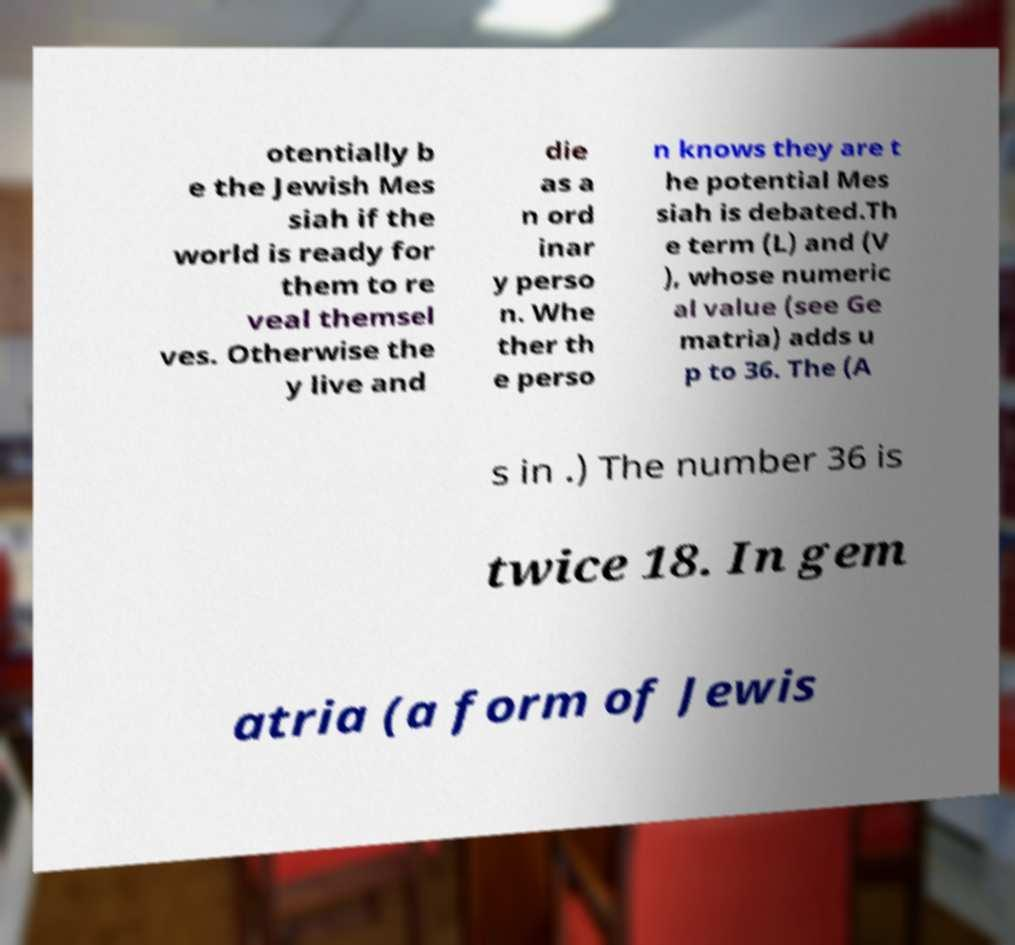Could you extract and type out the text from this image? otentially b e the Jewish Mes siah if the world is ready for them to re veal themsel ves. Otherwise the y live and die as a n ord inar y perso n. Whe ther th e perso n knows they are t he potential Mes siah is debated.Th e term (L) and (V ), whose numeric al value (see Ge matria) adds u p to 36. The (A s in .) The number 36 is twice 18. In gem atria (a form of Jewis 